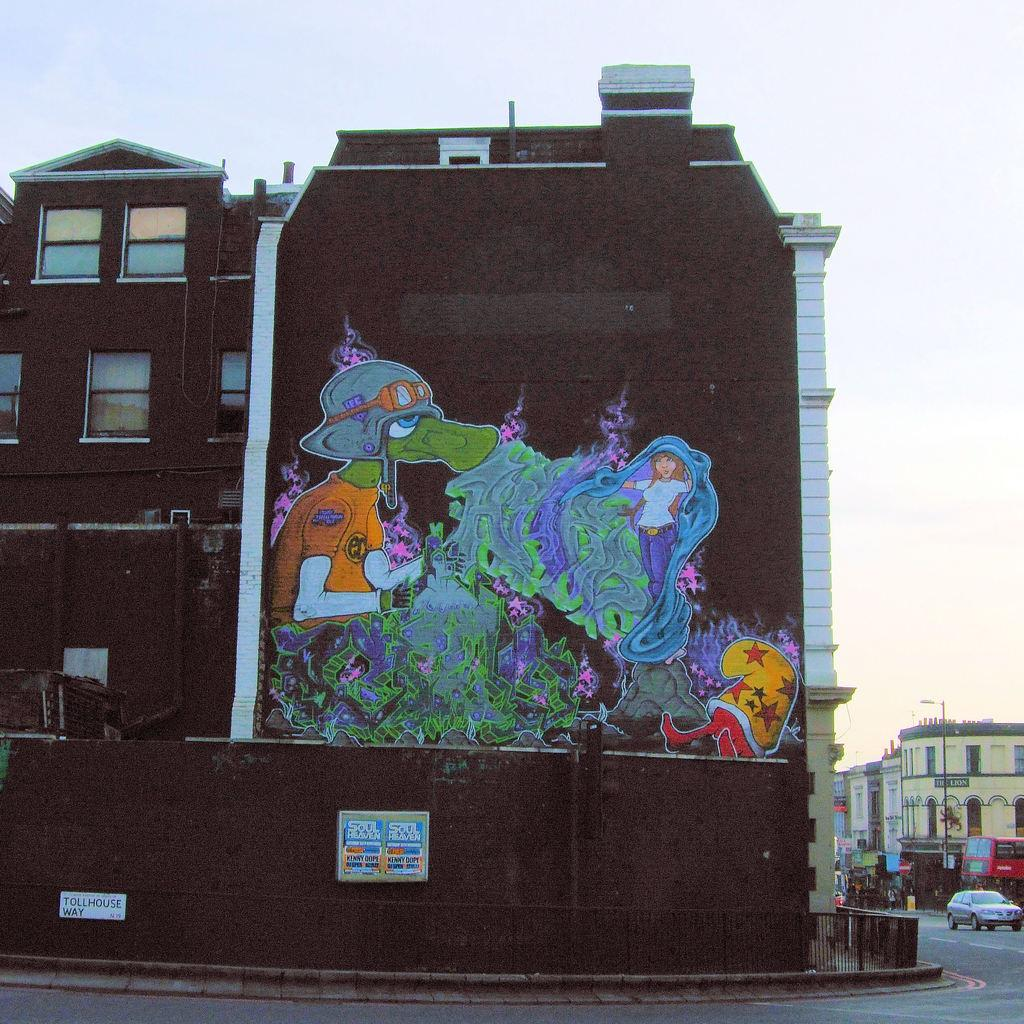What type of structures can be seen in the image? There are buildings in the image. What is happening on the road in the image? A car is moving on the road in the image. Can you describe the artwork on one of the buildings? There is a painting on the wall of a building in the image. What is the condition of the sky in the image? The sky is visible in the image and appears to be cloudy. What type of magic is being performed by the elbow in the image? There is no magic or elbow present in the image. 